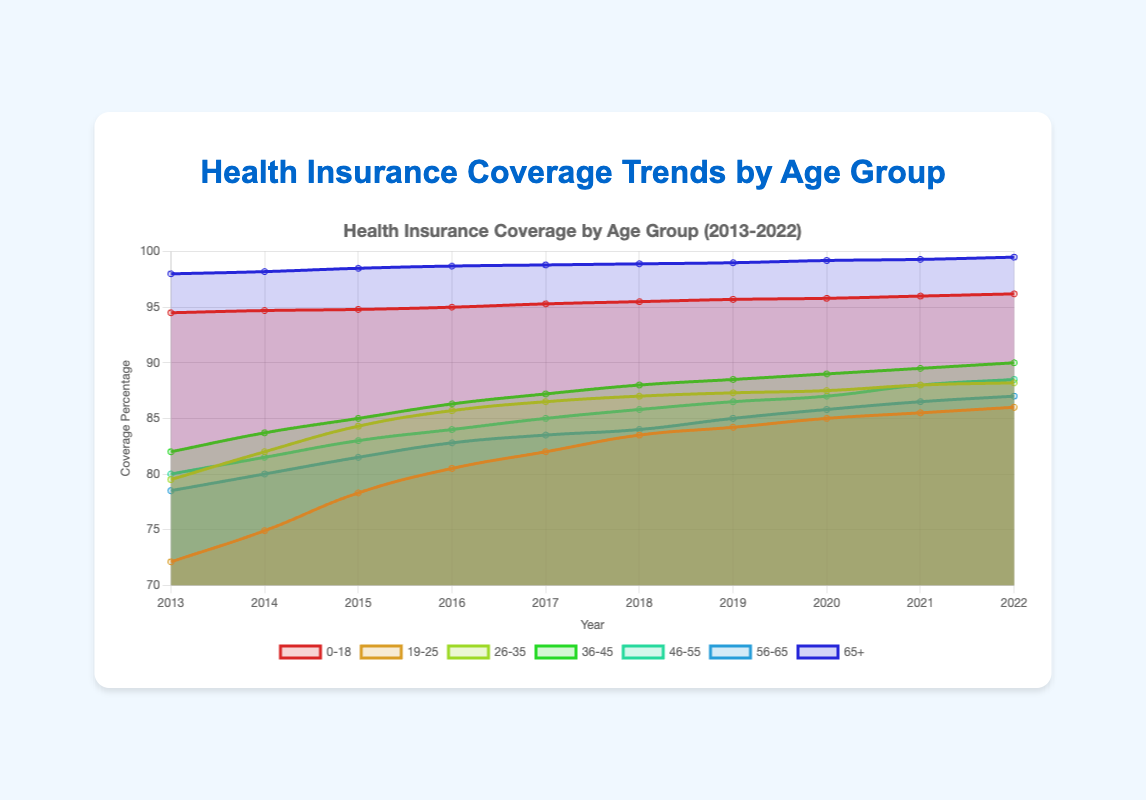What's the overall trend in health insurance coverage for the 0-18 age group from 2013 to 2022? Observing the line representing the 0-18 age group, it steadily increases from 94.5% in 2013 to 96.2% in 2022.
Answer: The coverage increases Which age group experienced the highest increase in insurance coverage from 2013 to 2022? Comparing the start and end points of each line, the 19-25 age group increased from 72.1% to 86.0%, representing the highest rise.
Answer: 19-25 What was the insurance coverage percentage for the 65+ age group in 2020? Looking at the line representing the 65+ age group and finding the point corresponding to 2020, it shows around 99.2%.
Answer: 99.2% Is there any age group that had consistently above 90% insurance coverage throughout the decade? By examining the lines, the 0-18 and 65+ age groups always stayed above 90% coverage from 2013 to 2022.
Answer: Yes, 0-18 and 65+ Which age group had the lowest insurance coverage in 2013? Observing the lines for 2013, the 19-25 age group had the lowest coverage at 72.1%.
Answer: 19-25 How much did health insurance coverage for the 26-35 age group increase from 2013 to 2022? The 26-35 age group increased from 79.5% in 2013 to 88.2% in 2022. The difference is 88.2% - 79.5% = 8.7%.
Answer: 8.7% Which age group had the smallest change in insurance coverage over the decade? The line for the 65+ age group shows a change from 98.0% to 99.5%, the smallest increase of just 1.5 percentage points.
Answer: 65+ How did the coverage percentage for the 46-55 age group change between 2014 and 2020? In 2014, coverage for 46-55 was 81.5%. By 2020, it increased to 87.0%. Thus, the change is 87.0% - 81.5% = 5.5%.
Answer: 5.5% Which age group reached a coverage percentage of around 85% first during the period? Observing the trend, the 19-25 age group first hit around 85% in 2019, ahead of other groups.
Answer: 19-25 What is the average insurance coverage for the 56-65 age group over the decade? Adding the values for the 56-65 group (78.5, 80.0, 81.5, 82.8, 83.5, 84.0, 85.0, 85.8, 86.5, 87.0) and dividing by 10: (10*(78.5+80.0+81.5+82.8+83.5+84.0+85.0+85.8+86.5+87.0))/10 = 84.46%
Answer: 84.46% 